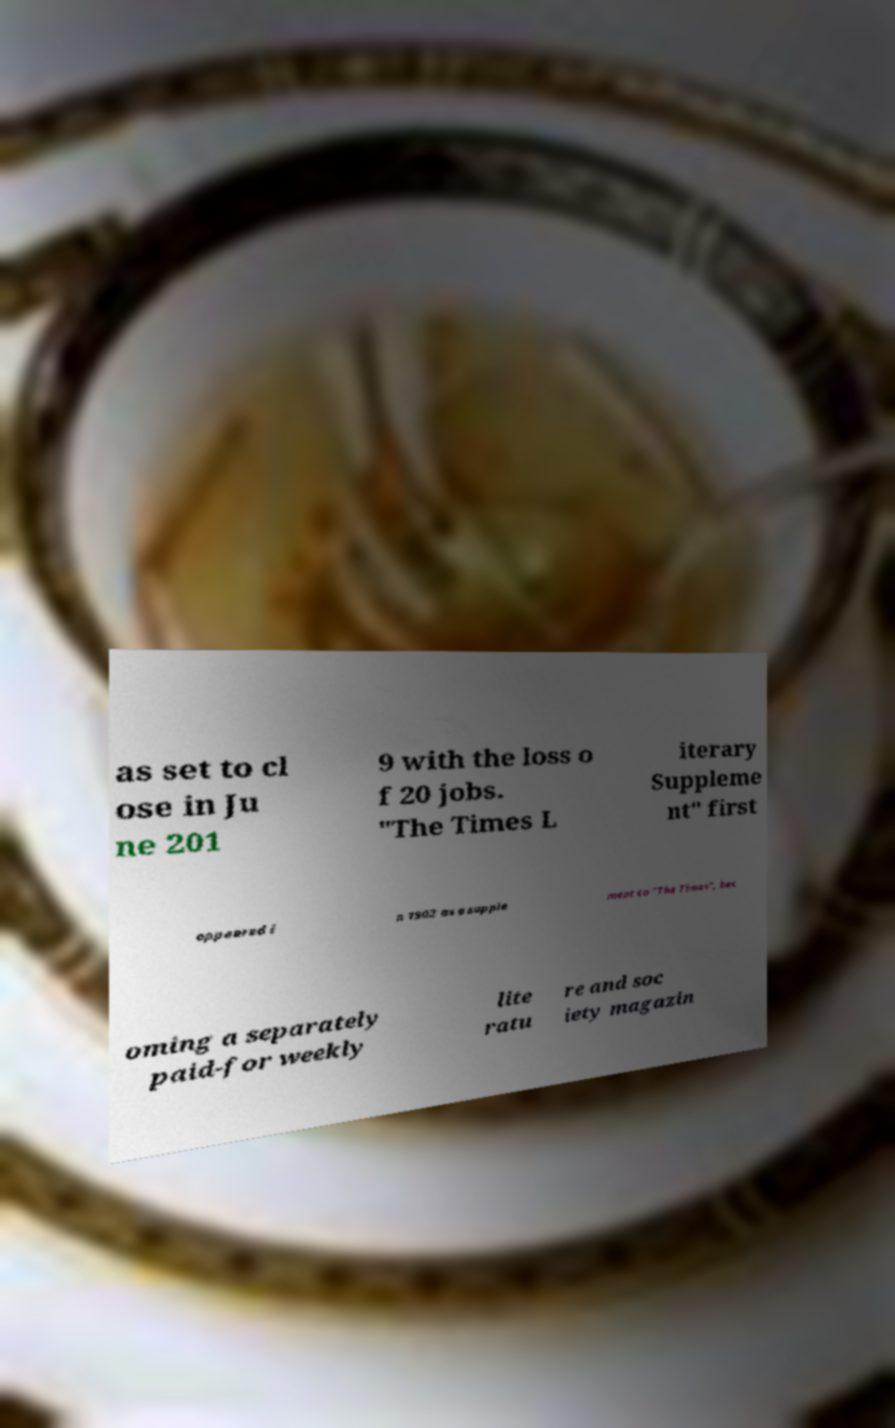Please read and relay the text visible in this image. What does it say? as set to cl ose in Ju ne 201 9 with the loss o f 20 jobs. "The Times L iterary Suppleme nt" first appeared i n 1902 as a supple ment to "The Times", bec oming a separately paid-for weekly lite ratu re and soc iety magazin 